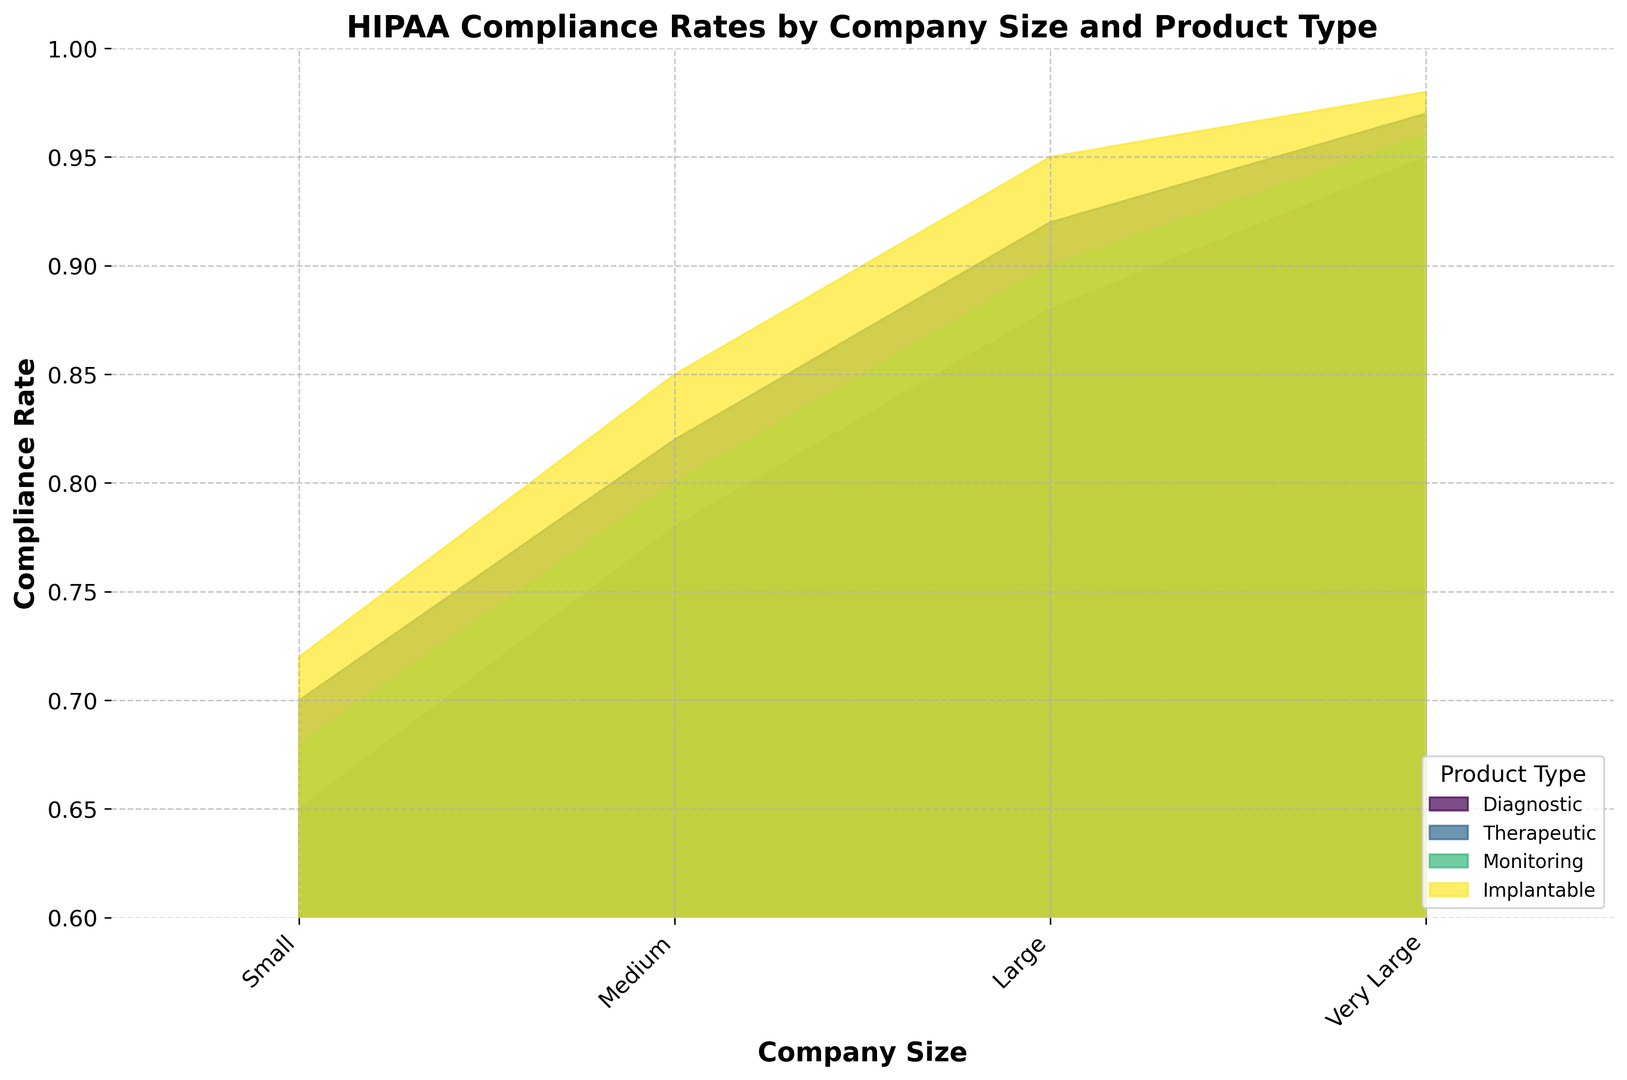What is the compliance rate for Medium-sized companies producing Diagnostic products? Look for the intersection between the "Medium" category on the x-axis and the section filled with the color representing "Diagnostic" products. The compliance rate for Medium-sized Diagnostic products is 0.78
Answer: 0.78 Which product type has the highest compliance rate for Small companies? In the "Small" category on the x-axis, identify the highest point among the different colors representing product types. Small companies producing "Implantable" products have the highest compliance rate at 0.72
Answer: Implantable How does the compliance rate of Large companies producing Monitoring products compare to that of Small companies producing the same product type? Compare the compliance rates between the Large and Small company categories for the "Monitoring" product type. Large companies have a compliance rate of 0.90, while Small companies have a compliance rate of 0.68
Answer: Large companies have a higher compliance rate Which company size has the lowest compliance rate for Therapeutic products? Identify the lowest point for the "Therapeutic" product type across all company sizes. The lowest compliance rate for Therapeutic products is found in Small companies at 0.70
Answer: Small What is the average compliance rate of Small companies across all product types? Sum the compliance rates for all product types in the "Small" category and divide by the number of product types: (0.65 + 0.70 + 0.68 + 0.72) / 4 = 0.6875
Answer: 0.69 Is there any product type where compliance rates are equal across all company sizes? Scan the plot to determine if there's a constant y-value (compliance rate) for any product type across all company sizes. Such a pattern does not exist; compliance rates vary across sizes for each product type
Answer: No Between Diagnostic and Implantable products, which ones have a higher compliance rate for Very Large companies? Compare the compliance rates for "Diagnostic" and "Implantable" products in the "Very Large" company category. Very Large companies have a compliance rate of 0.95 for Diagnostic and 0.98 for Implantable products
Answer: Implantable 